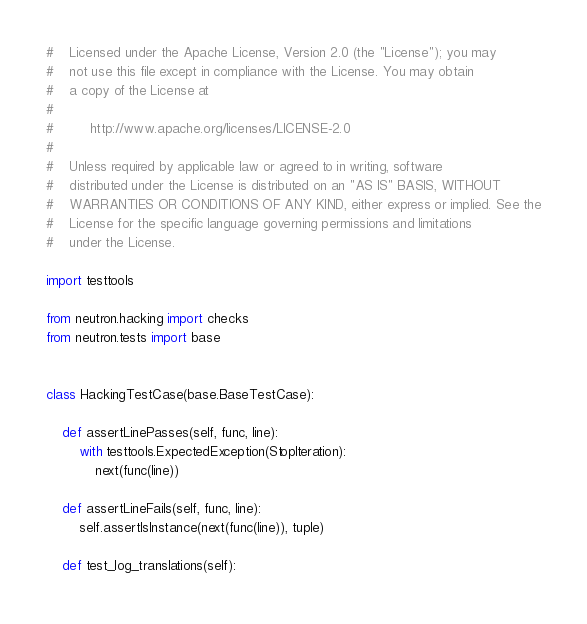<code> <loc_0><loc_0><loc_500><loc_500><_Python_>#    Licensed under the Apache License, Version 2.0 (the "License"); you may
#    not use this file except in compliance with the License. You may obtain
#    a copy of the License at
#
#         http://www.apache.org/licenses/LICENSE-2.0
#
#    Unless required by applicable law or agreed to in writing, software
#    distributed under the License is distributed on an "AS IS" BASIS, WITHOUT
#    WARRANTIES OR CONDITIONS OF ANY KIND, either express or implied. See the
#    License for the specific language governing permissions and limitations
#    under the License.

import testtools

from neutron.hacking import checks
from neutron.tests import base


class HackingTestCase(base.BaseTestCase):

    def assertLinePasses(self, func, line):
        with testtools.ExpectedException(StopIteration):
            next(func(line))

    def assertLineFails(self, func, line):
        self.assertIsInstance(next(func(line)), tuple)

    def test_log_translations(self):</code> 